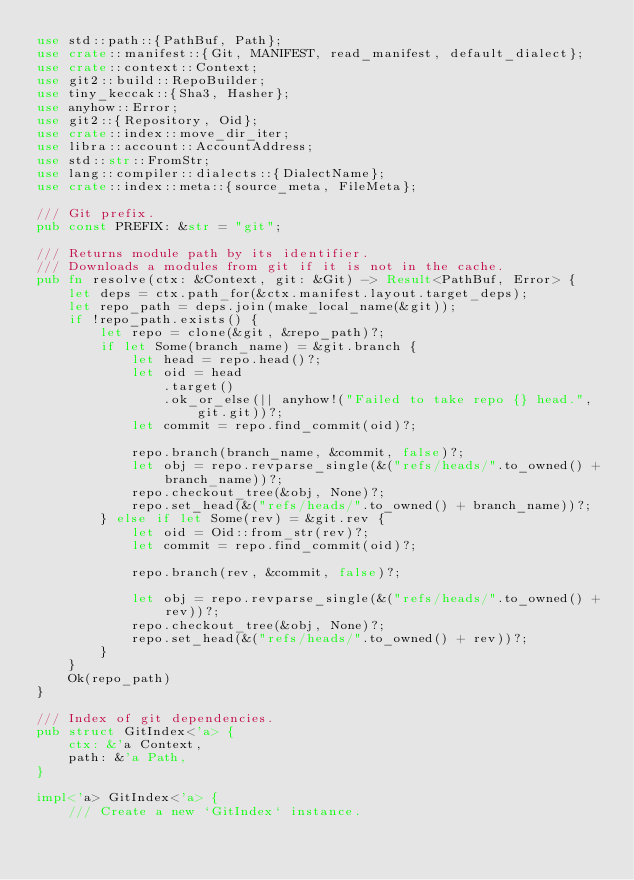<code> <loc_0><loc_0><loc_500><loc_500><_Rust_>use std::path::{PathBuf, Path};
use crate::manifest::{Git, MANIFEST, read_manifest, default_dialect};
use crate::context::Context;
use git2::build::RepoBuilder;
use tiny_keccak::{Sha3, Hasher};
use anyhow::Error;
use git2::{Repository, Oid};
use crate::index::move_dir_iter;
use libra::account::AccountAddress;
use std::str::FromStr;
use lang::compiler::dialects::{DialectName};
use crate::index::meta::{source_meta, FileMeta};

/// Git prefix.
pub const PREFIX: &str = "git";

/// Returns module path by its identifier.
/// Downloads a modules from git if it is not in the cache.
pub fn resolve(ctx: &Context, git: &Git) -> Result<PathBuf, Error> {
    let deps = ctx.path_for(&ctx.manifest.layout.target_deps);
    let repo_path = deps.join(make_local_name(&git));
    if !repo_path.exists() {
        let repo = clone(&git, &repo_path)?;
        if let Some(branch_name) = &git.branch {
            let head = repo.head()?;
            let oid = head
                .target()
                .ok_or_else(|| anyhow!("Failed to take repo {} head.", git.git))?;
            let commit = repo.find_commit(oid)?;

            repo.branch(branch_name, &commit, false)?;
            let obj = repo.revparse_single(&("refs/heads/".to_owned() + branch_name))?;
            repo.checkout_tree(&obj, None)?;
            repo.set_head(&("refs/heads/".to_owned() + branch_name))?;
        } else if let Some(rev) = &git.rev {
            let oid = Oid::from_str(rev)?;
            let commit = repo.find_commit(oid)?;

            repo.branch(rev, &commit, false)?;

            let obj = repo.revparse_single(&("refs/heads/".to_owned() + rev))?;
            repo.checkout_tree(&obj, None)?;
            repo.set_head(&("refs/heads/".to_owned() + rev))?;
        }
    }
    Ok(repo_path)
}

/// Index of git dependencies.
pub struct GitIndex<'a> {
    ctx: &'a Context,
    path: &'a Path,
}

impl<'a> GitIndex<'a> {
    /// Create a new `GitIndex` instance.</code> 